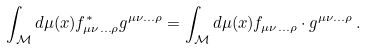Convert formula to latex. <formula><loc_0><loc_0><loc_500><loc_500>\int _ { \mathcal { M } } d \mu ( x ) f _ { \mu \nu \dots \rho } ^ { * } g ^ { \mu \nu \dots \rho } = \int _ { \mathcal { M } } d \mu ( x ) f _ { \mu \nu \dots \rho } \cdot g ^ { \mu \nu \dots \rho } \, .</formula> 